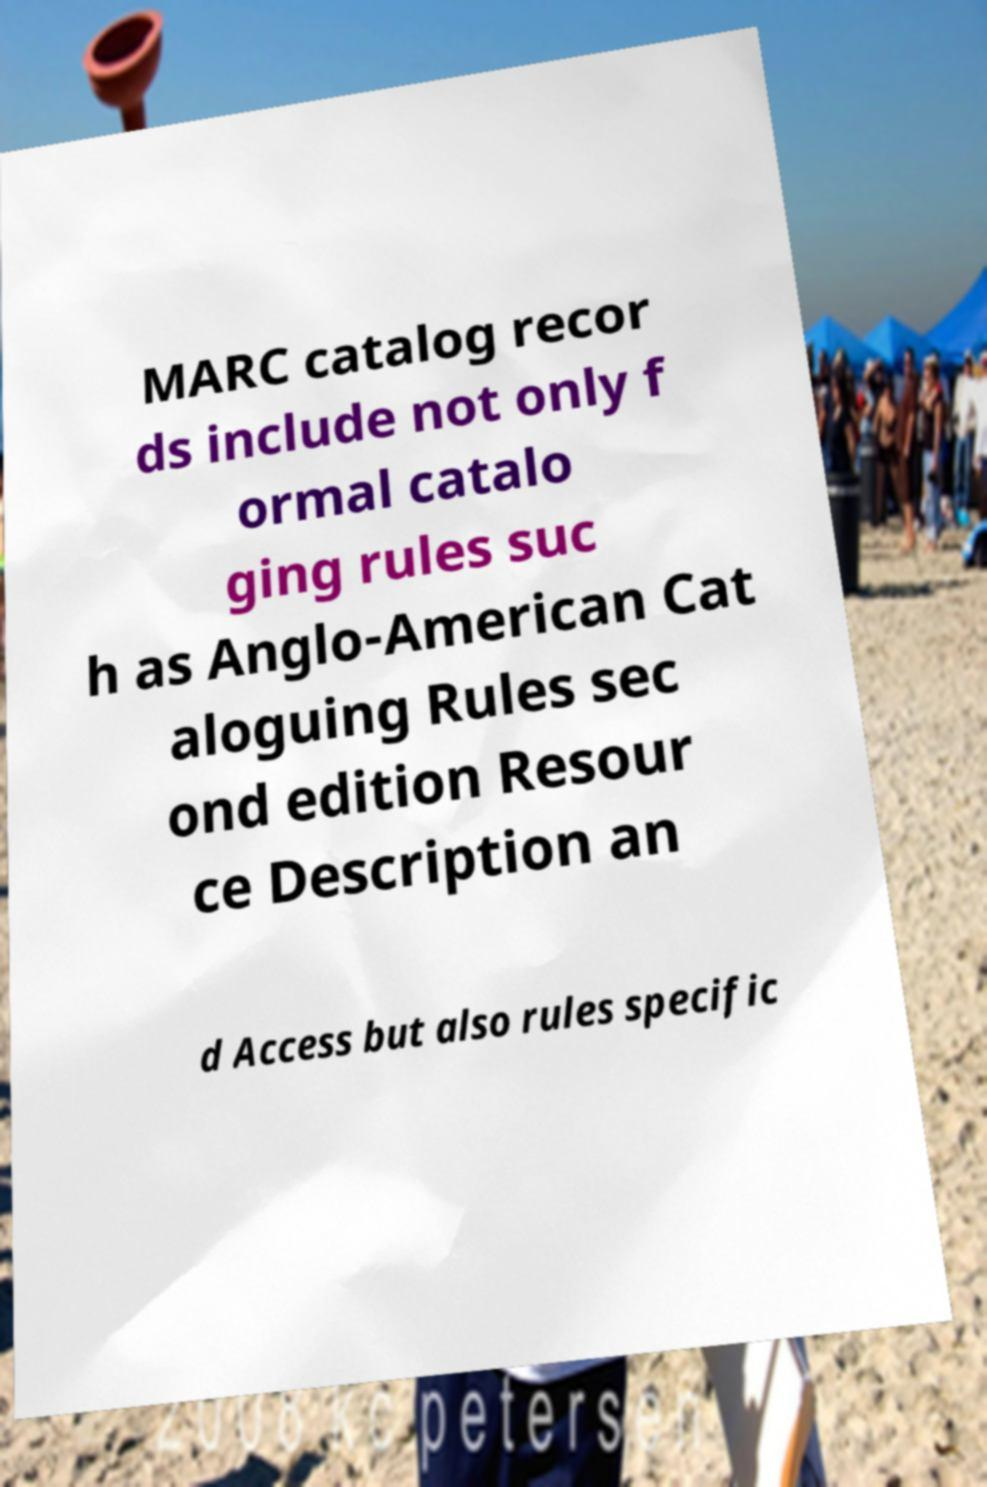I need the written content from this picture converted into text. Can you do that? MARC catalog recor ds include not only f ormal catalo ging rules suc h as Anglo-American Cat aloguing Rules sec ond edition Resour ce Description an d Access but also rules specific 